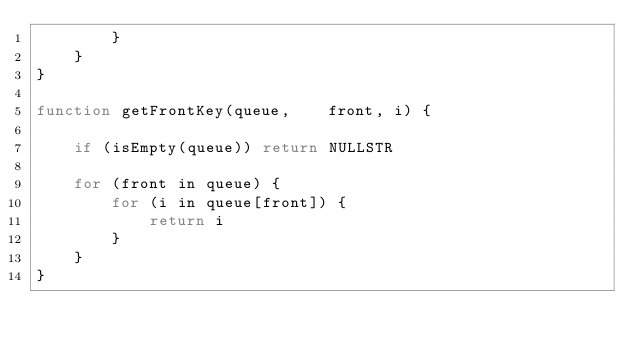Convert code to text. <code><loc_0><loc_0><loc_500><loc_500><_Awk_>        }
    }
}

function getFrontKey(queue,    front, i) {

    if (isEmpty(queue)) return NULLSTR

    for (front in queue) {
        for (i in queue[front]) {
            return i
        }
    }
}
</code> 